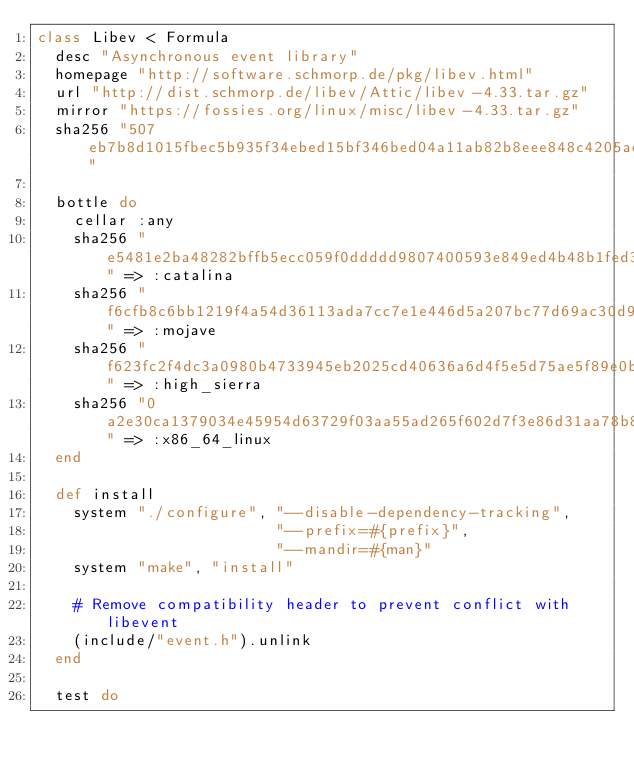Convert code to text. <code><loc_0><loc_0><loc_500><loc_500><_Ruby_>class Libev < Formula
  desc "Asynchronous event library"
  homepage "http://software.schmorp.de/pkg/libev.html"
  url "http://dist.schmorp.de/libev/Attic/libev-4.33.tar.gz"
  mirror "https://fossies.org/linux/misc/libev-4.33.tar.gz"
  sha256 "507eb7b8d1015fbec5b935f34ebed15bf346bed04a11ab82b8eee848c4205aea"

  bottle do
    cellar :any
    sha256 "e5481e2ba48282bffb5ecc059f0ddddd9807400593e849ed4b48b1fed3a14698" => :catalina
    sha256 "f6cfb8c6bb1219f4a54d36113ada7cc7e1e446d5a207bc77d69ac30d9cfe391f" => :mojave
    sha256 "f623fc2f4dc3a0980b4733945eb2025cd40636a6d4f5e5d75ae5f89e0b7b07bd" => :high_sierra
    sha256 "0a2e30ca1379034e45954d63729f03aa55ad265f602d7f3e86d31aa78b81b292" => :x86_64_linux
  end

  def install
    system "./configure", "--disable-dependency-tracking",
                          "--prefix=#{prefix}",
                          "--mandir=#{man}"
    system "make", "install"

    # Remove compatibility header to prevent conflict with libevent
    (include/"event.h").unlink
  end

  test do</code> 